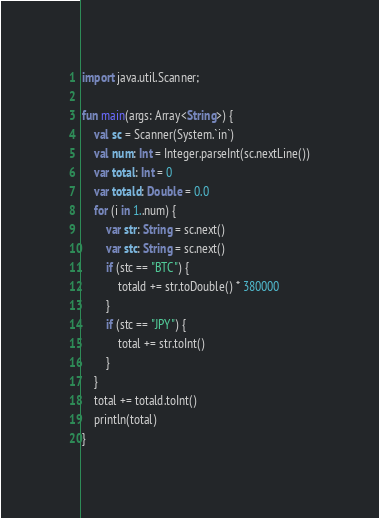Convert code to text. <code><loc_0><loc_0><loc_500><loc_500><_Kotlin_>import java.util.Scanner;

fun main(args: Array<String>) {
	val sc = Scanner(System.`in`)
	val num: Int = Integer.parseInt(sc.nextLine())
	var total: Int = 0
	var totald: Double = 0.0
	for (i in 1..num) {
		var str: String = sc.next()
		var stc: String = sc.next()
		if (stc == "BTC") {
			totald += str.toDouble() * 380000
		}
		if (stc == "JPY") {
			total += str.toInt()
		}
	}
	total += totald.toInt()
	println(total)
}</code> 